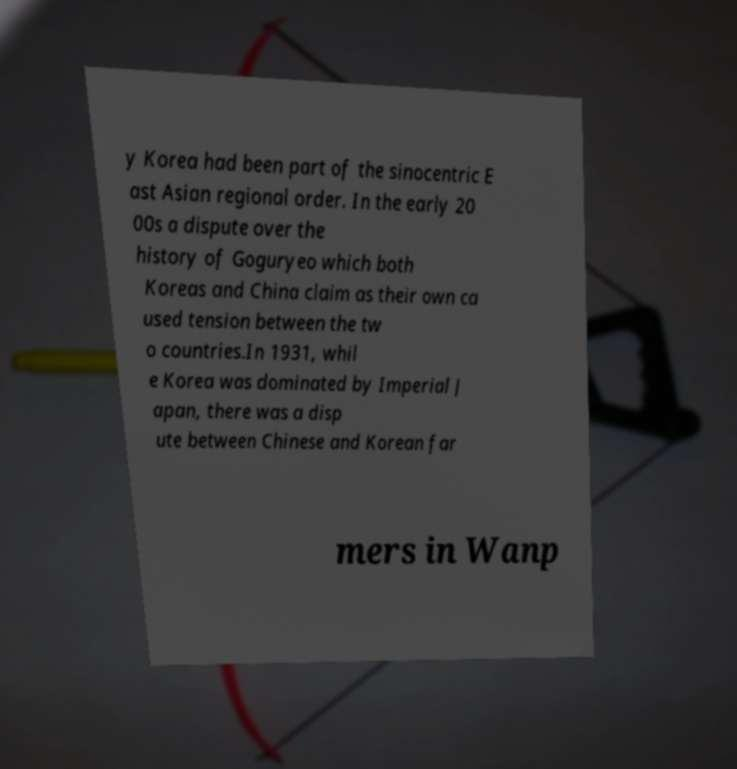What messages or text are displayed in this image? I need them in a readable, typed format. y Korea had been part of the sinocentric E ast Asian regional order. In the early 20 00s a dispute over the history of Goguryeo which both Koreas and China claim as their own ca used tension between the tw o countries.In 1931, whil e Korea was dominated by Imperial J apan, there was a disp ute between Chinese and Korean far mers in Wanp 